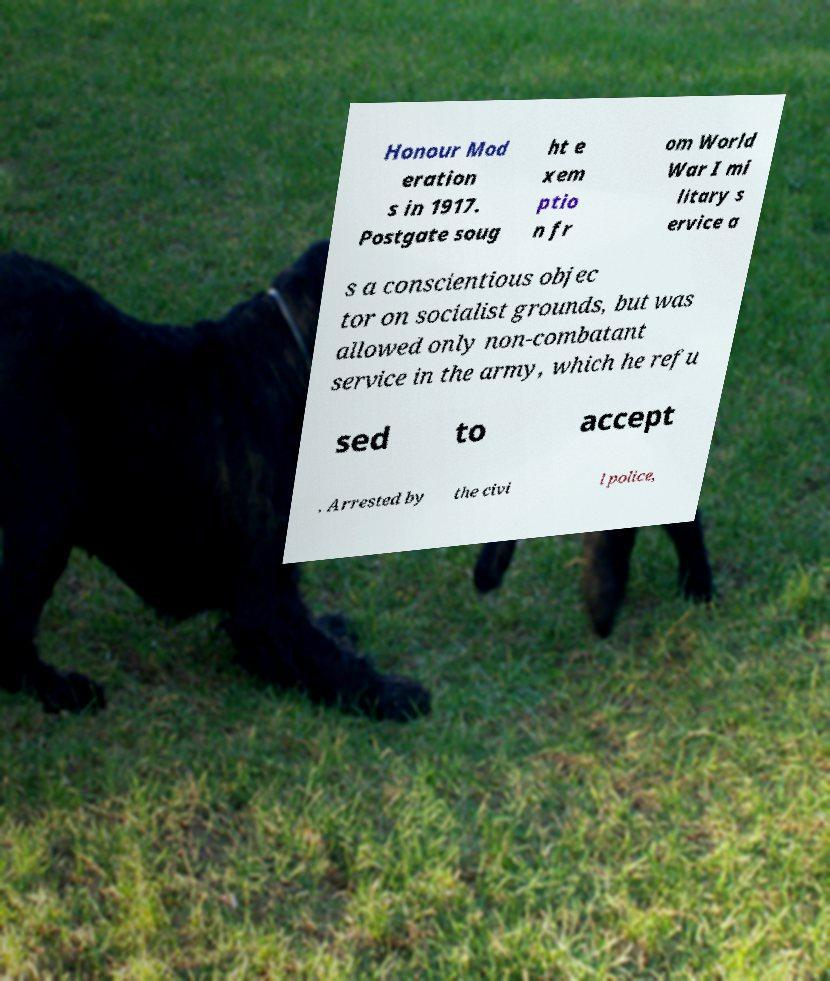What messages or text are displayed in this image? I need them in a readable, typed format. Honour Mod eration s in 1917. Postgate soug ht e xem ptio n fr om World War I mi litary s ervice a s a conscientious objec tor on socialist grounds, but was allowed only non-combatant service in the army, which he refu sed to accept . Arrested by the civi l police, 